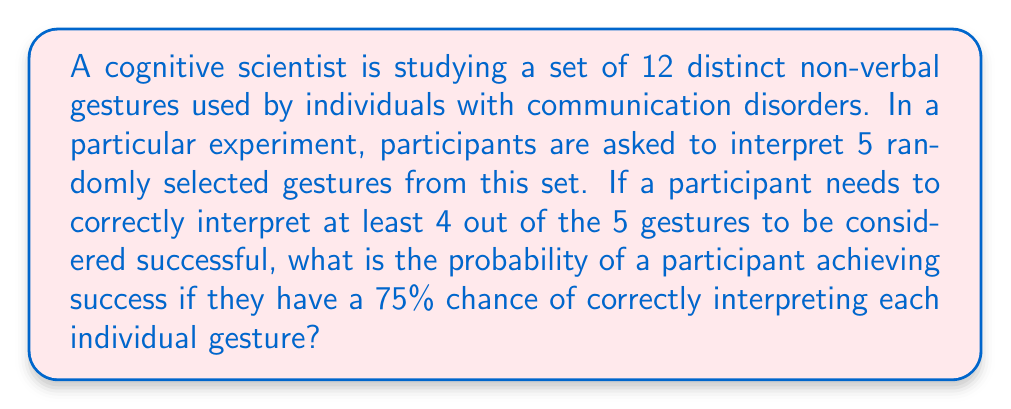Provide a solution to this math problem. Let's approach this step-by-step:

1) First, we need to recognize that this is a binomial probability problem. We're looking for the probability of at least 4 successes out of 5 trials.

2) The probability of success for each trial (correctly interpreting a gesture) is 75% or 0.75.

3) We need to calculate the probability of exactly 4 successes and exactly 5 successes, then add these together.

4) The probability of exactly k successes in n trials is given by the binomial probability formula:

   $$ P(X = k) = \binom{n}{k} p^k (1-p)^{n-k} $$

   where $n$ is the number of trials, $k$ is the number of successes, $p$ is the probability of success on each trial.

5) For 4 successes out of 5:

   $$ P(X = 4) = \binom{5}{4} (0.75)^4 (0.25)^1 $$
   $$ = 5 \cdot (0.75)^4 \cdot 0.25 = 0.3955 $$

6) For 5 successes out of 5:

   $$ P(X = 5) = \binom{5}{5} (0.75)^5 (0.25)^0 $$
   $$ = 1 \cdot (0.75)^5 = 0.2373 $$

7) The probability of at least 4 successes is the sum of these probabilities:

   $$ P(X \geq 4) = P(X = 4) + P(X = 5) = 0.3955 + 0.2373 = 0.6328 $$
Answer: The probability of a participant achieving success (correctly interpreting at least 4 out of 5 gestures) is approximately 0.6328 or 63.28%. 